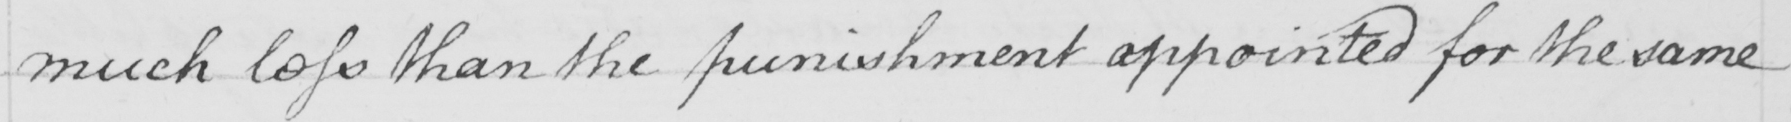Please provide the text content of this handwritten line. much less than the punishment appointed for the same 